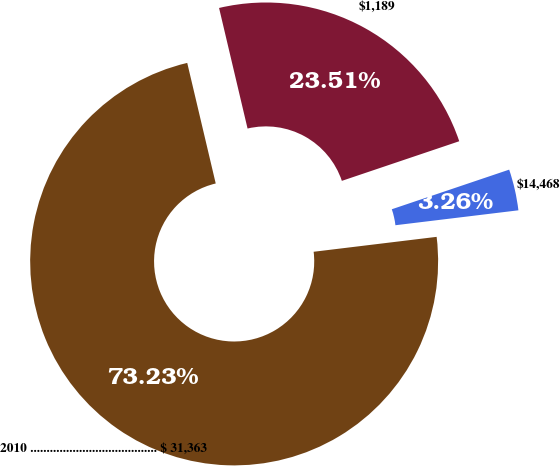Convert chart. <chart><loc_0><loc_0><loc_500><loc_500><pie_chart><fcel>2010 ....................................... $ 31,363<fcel>$1,189<fcel>$14,468<nl><fcel>73.22%<fcel>23.51%<fcel>3.26%<nl></chart> 